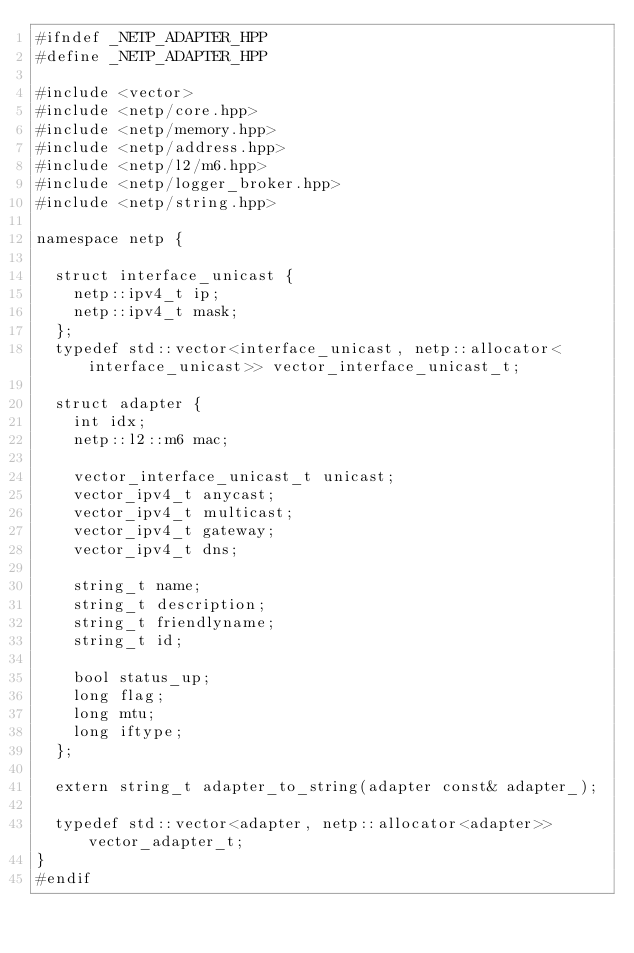<code> <loc_0><loc_0><loc_500><loc_500><_C++_>#ifndef _NETP_ADAPTER_HPP
#define _NETP_ADAPTER_HPP

#include <vector>
#include <netp/core.hpp>
#include <netp/memory.hpp>
#include <netp/address.hpp>
#include <netp/l2/m6.hpp>
#include <netp/logger_broker.hpp>
#include <netp/string.hpp>

namespace netp {

	struct interface_unicast {
		netp::ipv4_t ip;
		netp::ipv4_t mask;
	};
	typedef std::vector<interface_unicast, netp::allocator<interface_unicast>> vector_interface_unicast_t;

	struct adapter {
		int idx;
		netp::l2::m6 mac;
		
		vector_interface_unicast_t unicast;
		vector_ipv4_t anycast;
		vector_ipv4_t multicast;
		vector_ipv4_t gateway;
		vector_ipv4_t dns;

		string_t name;
		string_t description;
		string_t friendlyname;
		string_t id;

		bool status_up;
		long flag;
		long mtu;
		long iftype;
	};

	extern string_t adapter_to_string(adapter const& adapter_);

	typedef std::vector<adapter, netp::allocator<adapter>> vector_adapter_t;
}
#endif</code> 